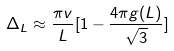<formula> <loc_0><loc_0><loc_500><loc_500>\Delta _ { L } \approx \frac { \pi v } { L } [ 1 - \frac { 4 \pi g ( L ) } { \sqrt { 3 } } ]</formula> 